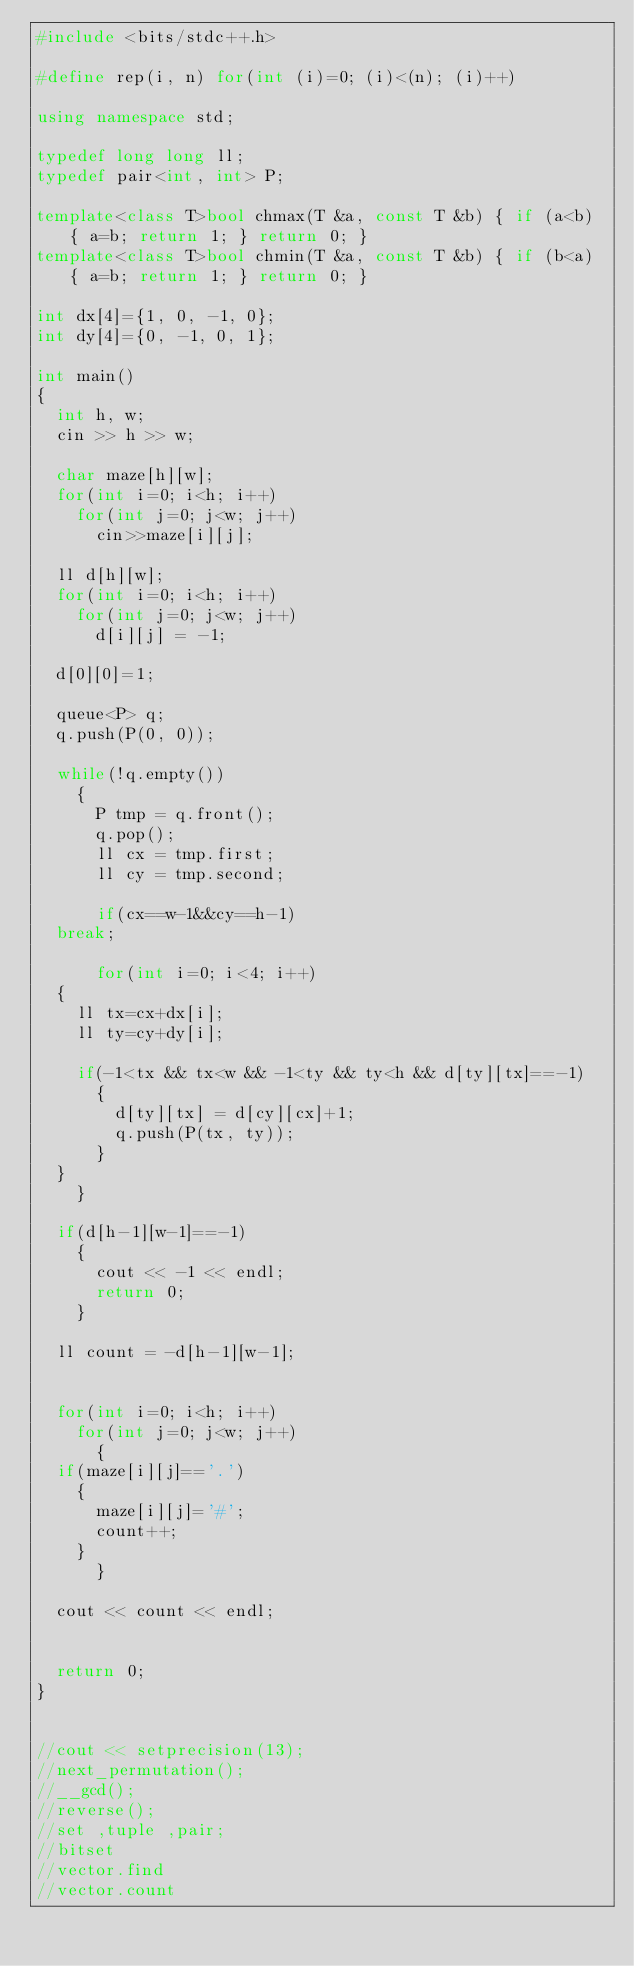<code> <loc_0><loc_0><loc_500><loc_500><_C++_>#include <bits/stdc++.h>

#define rep(i, n) for(int (i)=0; (i)<(n); (i)++)

using namespace std;

typedef long long ll;
typedef pair<int, int> P;

template<class T>bool chmax(T &a, const T &b) { if (a<b) { a=b; return 1; } return 0; }
template<class T>bool chmin(T &a, const T &b) { if (b<a) { a=b; return 1; } return 0; }

int dx[4]={1, 0, -1, 0};
int dy[4]={0, -1, 0, 1};

int main()
{
  int h, w;
  cin >> h >> w;

  char maze[h][w];
  for(int i=0; i<h; i++)
    for(int j=0; j<w; j++)
      cin>>maze[i][j];

  ll d[h][w];
  for(int i=0; i<h; i++)
    for(int j=0; j<w; j++)
      d[i][j] = -1;
  
  d[0][0]=1;
  
  queue<P> q;
  q.push(P(0, 0));
    
  while(!q.empty())
    {
      P tmp = q.front();
      q.pop();
      ll cx = tmp.first;
      ll cy = tmp.second;

      if(cx==w-1&&cy==h-1)
	break;
      
      for(int i=0; i<4; i++)
	{
	  ll tx=cx+dx[i];
	  ll ty=cy+dy[i];

	  if(-1<tx && tx<w && -1<ty && ty<h && d[ty][tx]==-1)
	    {
	      d[ty][tx] = d[cy][cx]+1;
	      q.push(P(tx, ty));
	    }
	}
    }

  if(d[h-1][w-1]==-1)
    {
      cout << -1 << endl;
      return 0;
    }

  ll count = -d[h-1][w-1];


  for(int i=0; i<h; i++)
    for(int j=0; j<w; j++)
      {
	if(maze[i][j]=='.')
	  {
	    maze[i][j]='#';
	    count++;
	  }
      }

  cout << count << endl;
  

  return 0;
}


//cout << setprecision(13);
//next_permutation();
//__gcd();
//reverse();
//set ,tuple ,pair;
//bitset
//vector.find
//vector.count

</code> 